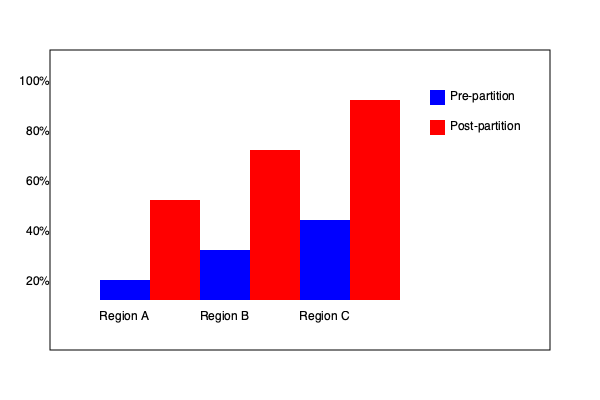Based on the bar graph comparing women's literacy rates in three regions before and after partition, which region showed the largest absolute increase in literacy rate post-partition? To determine which region showed the largest absolute increase in literacy rate post-partition, we need to:

1. Identify the pre-partition and post-partition literacy rates for each region:

   Region A:
   Pre-partition: 20%
   Post-partition: 50%

   Region B:
   Pre-partition: 25%
   Post-partition: 75%

   Region C:
   Pre-partition: 40%
   Post-partition: 100%

2. Calculate the absolute increase for each region:

   Region A: 50% - 20% = 30%
   Region B: 75% - 25% = 50%
   Region C: 100% - 40% = 60%

3. Compare the increases:

   Region A: 30%
   Region B: 50%
   Region C: 60%

The largest absolute increase is in Region C, with a 60% increase in literacy rate post-partition.
Answer: Region C 